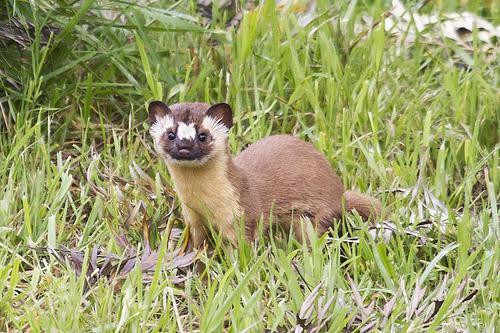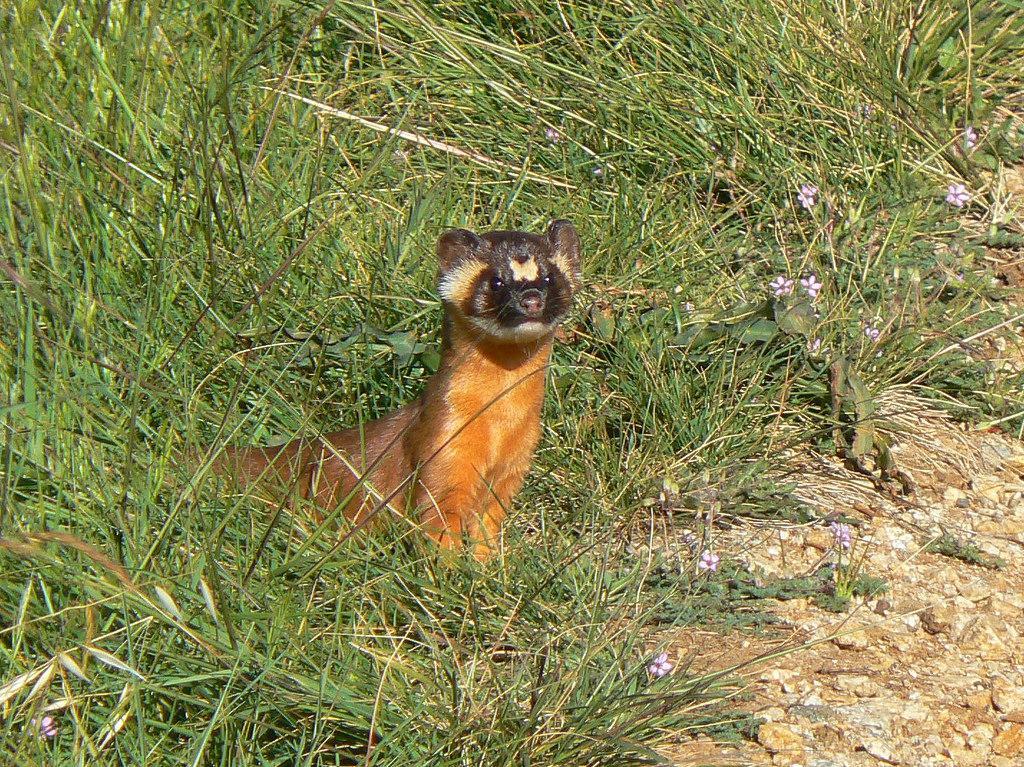The first image is the image on the left, the second image is the image on the right. For the images shown, is this caption "One image includes a ferret with closed eyes and open mouth on textured white bedding." true? Answer yes or no. No. The first image is the image on the left, the second image is the image on the right. Evaluate the accuracy of this statement regarding the images: "Two adult ferrets can be seen.". Is it true? Answer yes or no. Yes. 